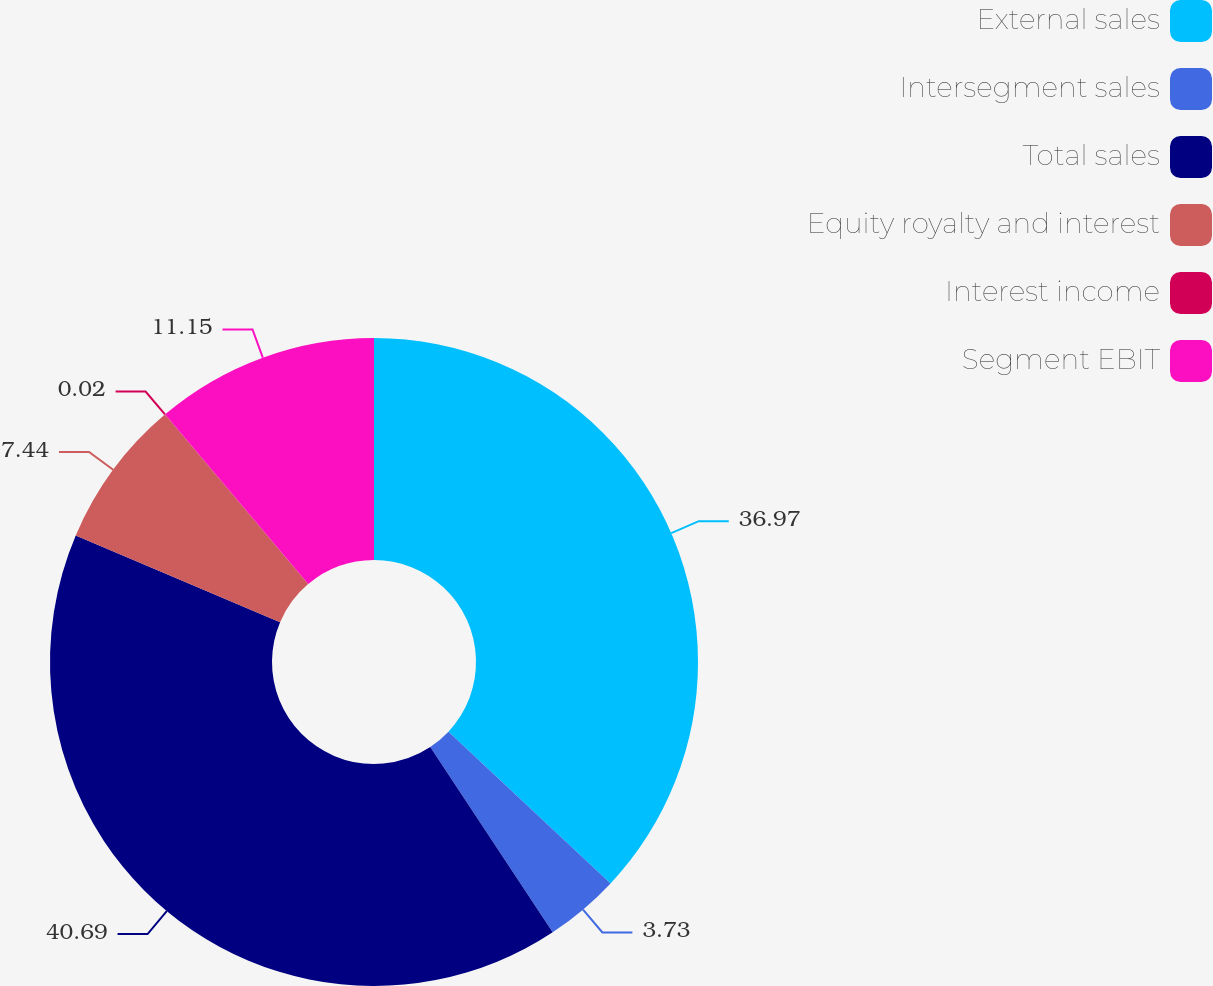<chart> <loc_0><loc_0><loc_500><loc_500><pie_chart><fcel>External sales<fcel>Intersegment sales<fcel>Total sales<fcel>Equity royalty and interest<fcel>Interest income<fcel>Segment EBIT<nl><fcel>36.97%<fcel>3.73%<fcel>40.68%<fcel>7.44%<fcel>0.02%<fcel>11.15%<nl></chart> 